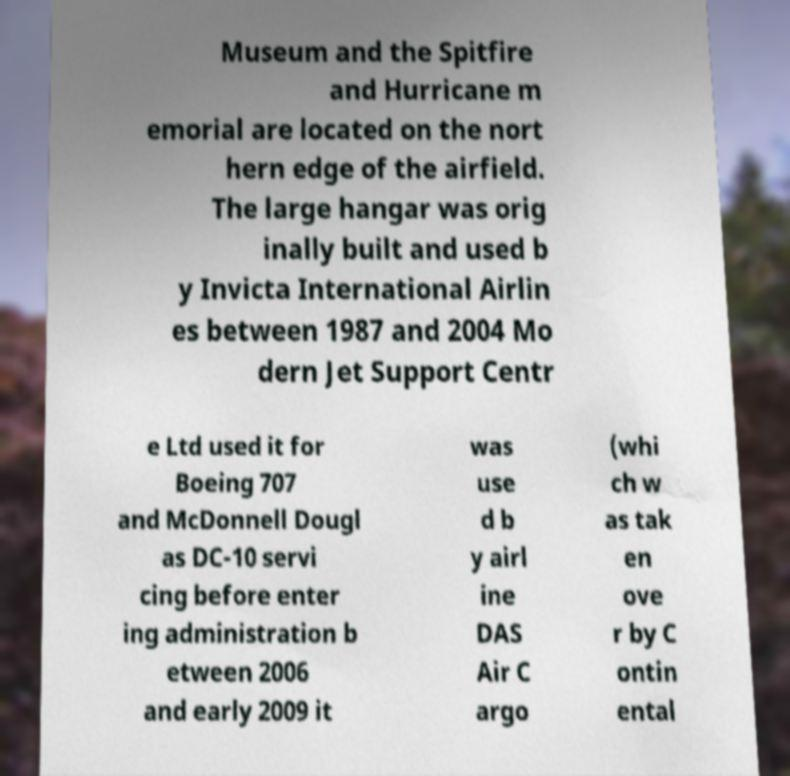Can you read and provide the text displayed in the image?This photo seems to have some interesting text. Can you extract and type it out for me? Museum and the Spitfire and Hurricane m emorial are located on the nort hern edge of the airfield. The large hangar was orig inally built and used b y Invicta International Airlin es between 1987 and 2004 Mo dern Jet Support Centr e Ltd used it for Boeing 707 and McDonnell Dougl as DC-10 servi cing before enter ing administration b etween 2006 and early 2009 it was use d b y airl ine DAS Air C argo (whi ch w as tak en ove r by C ontin ental 